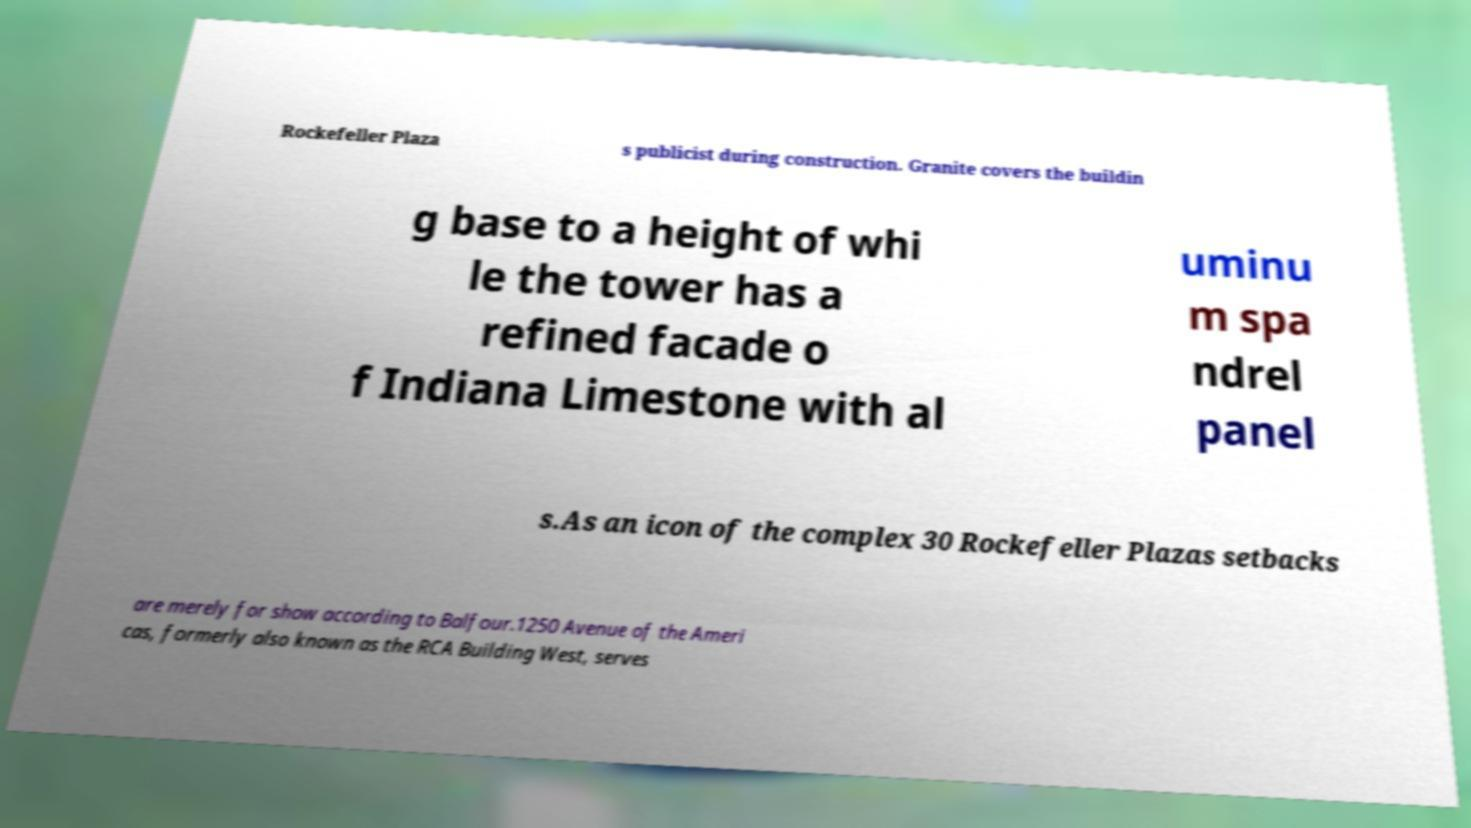For documentation purposes, I need the text within this image transcribed. Could you provide that? Rockefeller Plaza s publicist during construction. Granite covers the buildin g base to a height of whi le the tower has a refined facade o f Indiana Limestone with al uminu m spa ndrel panel s.As an icon of the complex 30 Rockefeller Plazas setbacks are merely for show according to Balfour.1250 Avenue of the Ameri cas, formerly also known as the RCA Building West, serves 